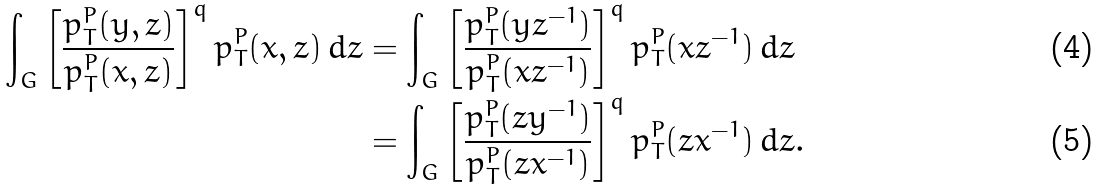Convert formula to latex. <formula><loc_0><loc_0><loc_500><loc_500>\int _ { G } \left [ \frac { p ^ { P } _ { T } ( y , z ) } { p ^ { P } _ { T } ( x , z ) } \right ] ^ { q } p ^ { P } _ { T } ( x , z ) \, d z & = \int _ { G } \left [ \frac { p ^ { P } _ { T } ( y z ^ { - 1 } ) } { p ^ { P } _ { T } ( x z ^ { - 1 } ) } \right ] ^ { q } p ^ { P } _ { T } ( x z ^ { - 1 } ) \, d z \\ & = \int _ { G } \left [ \frac { p ^ { P } _ { T } ( z y ^ { - 1 } ) } { p ^ { P } _ { T } ( z x ^ { - 1 } ) } \right ] ^ { q } p ^ { P } _ { T } ( z x ^ { - 1 } ) \, d z .</formula> 